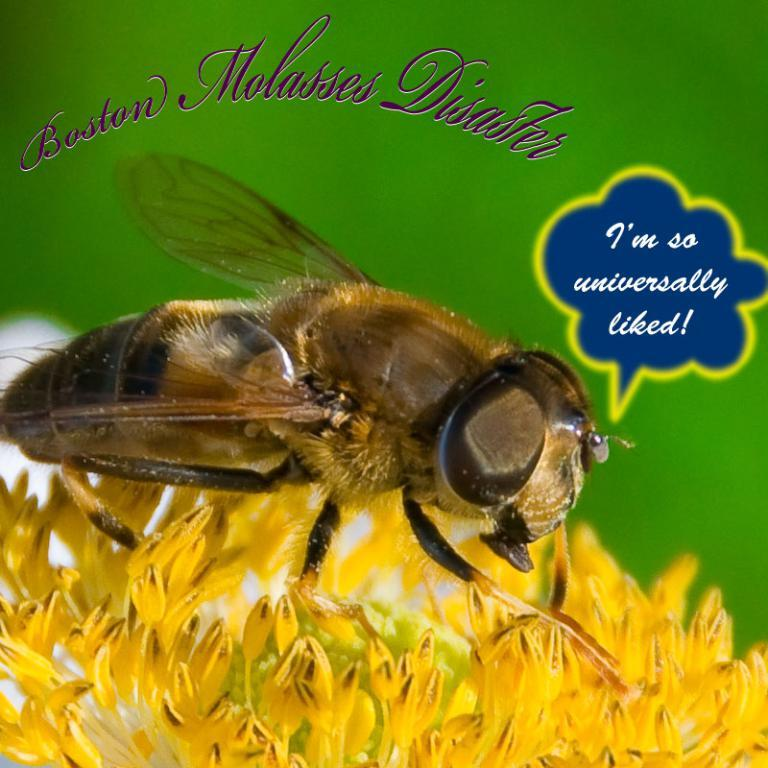What type of editing has been done to the image? The image is edited, but the specific type of editing is not mentioned in the facts. What can be seen on the flower in the image? A fly is present on the yellow flower in the image. What is the color of the flower in the image? The flower in the image is yellow. What is visible in the background of the image? There are texts visible in the background of the image, and the background has a green color. What type of poison is the fly carrying on the yellow flower? There is no mention of poison in the image, and the fly is not carrying any poison. What letters can be seen on the carpenter's toolbox in the image? There is no carpenter or toolbox present in the image. 